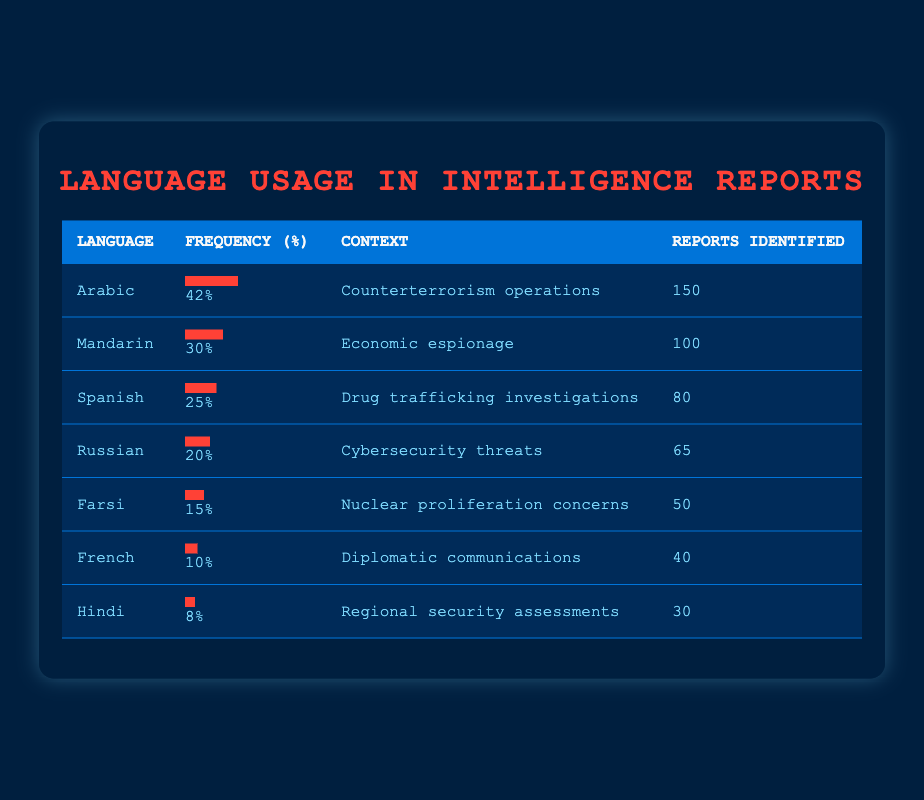What language has the highest frequency in intelligence reports? The table shows that Arabic has the highest frequency at 42%.
Answer: Arabic What percentage of reports identified for Spanish? From the table, Spanish is listed with a frequency of 25%.
Answer: 25% Is Farsi used in more reports than French? Farsi is identified in 50 reports while French is in 40 reports, confirming that Farsi is used in more reports than French.
Answer: Yes What is the average frequency of the languages listed in the table? To find the average frequency, sum the frequencies: 42 + 30 + 25 + 20 + 15 + 10 + 8 = 150. Then divide by the number of languages (7) which gives us 150 / 7 = about 21.43%.
Answer: 21.43% Which language has a frequency of 15%? The table indicates that Farsi has a frequency of 15%.
Answer: Farsi How many reports are identified for languages with a frequency greater than 20%? The languages with a frequency greater than 20% are Arabic, Mandarin, and Spanish. Adding their reports identified: 150 (Arabic) + 100 (Mandarin) + 80 (Spanish) = 330 reports.
Answer: 330 Does the frequency of Hindi exceed that of Farsi? Hindi has a frequency of 8%, which does not exceed Farsi's frequency of 15%.
Answer: No What is the difference in frequency between the language with the highest and the lowest frequency? The highest frequency is Arabic at 42% and the lowest is Hindi at 8%. The difference is 42 - 8 = 34%.
Answer: 34% 